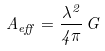Convert formula to latex. <formula><loc_0><loc_0><loc_500><loc_500>A _ { e f f } = { \frac { \lambda ^ { 2 } } { 4 \pi } } \, G</formula> 